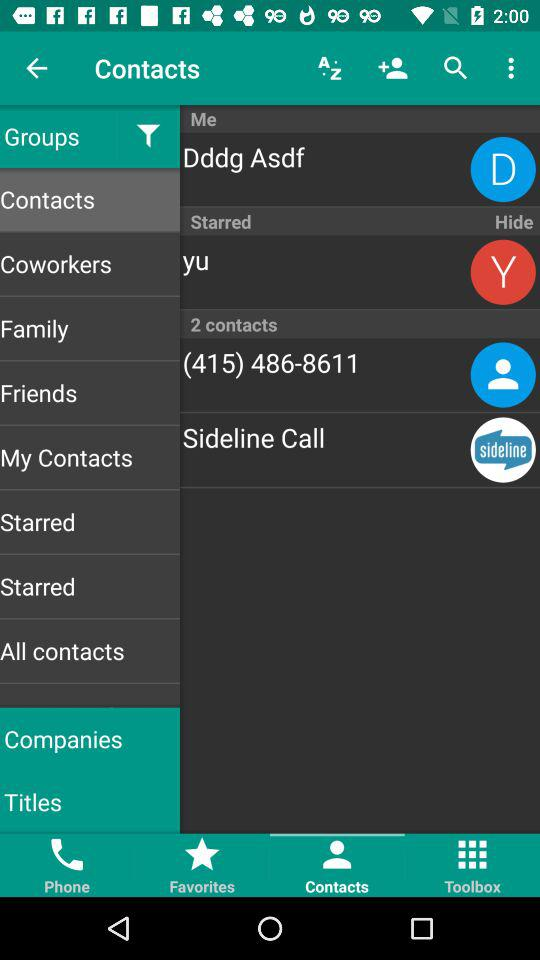What is the selected tab? The selected tab is "Contacts". 